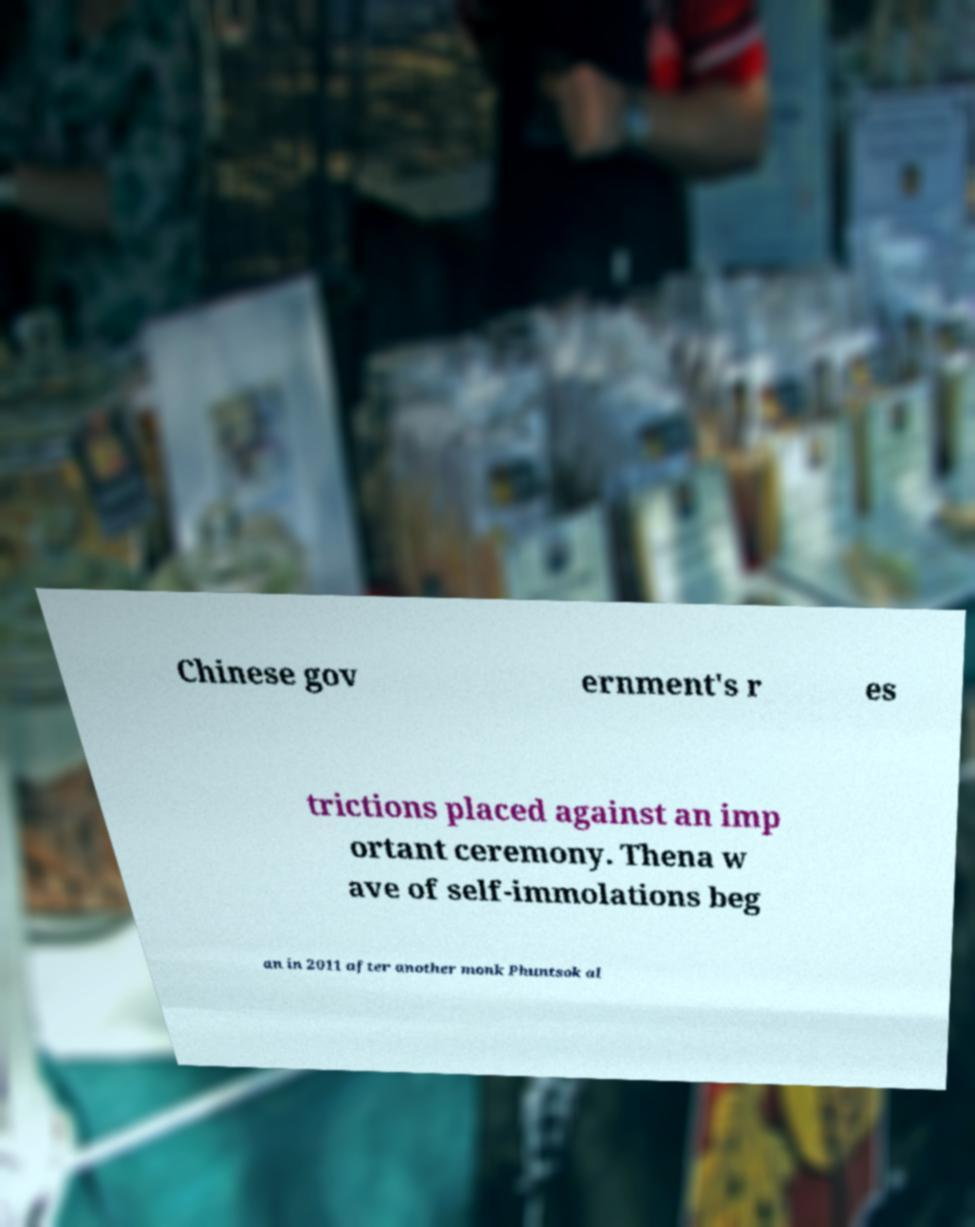Could you assist in decoding the text presented in this image and type it out clearly? Chinese gov ernment's r es trictions placed against an imp ortant ceremony. Thena w ave of self-immolations beg an in 2011 after another monk Phuntsok al 